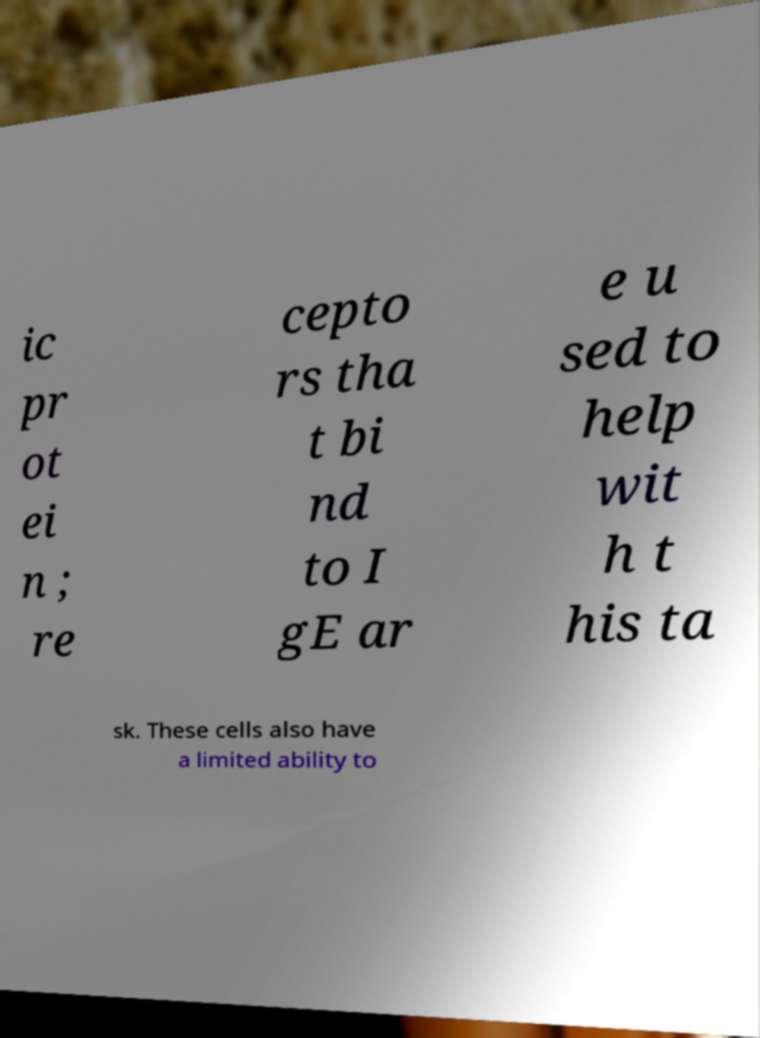Please identify and transcribe the text found in this image. ic pr ot ei n ; re cepto rs tha t bi nd to I gE ar e u sed to help wit h t his ta sk. These cells also have a limited ability to 